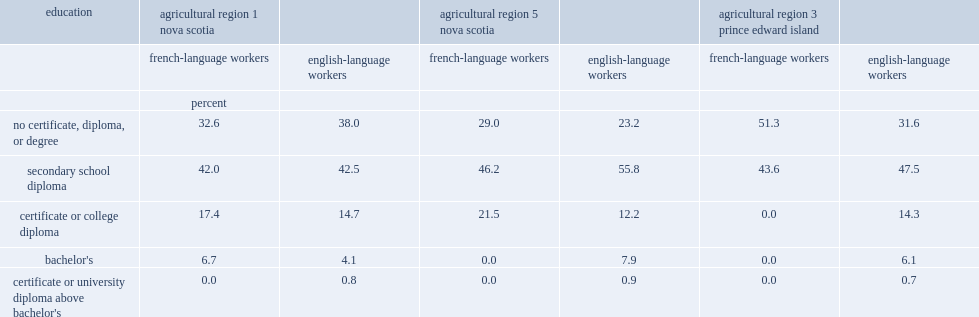Which sector of workers in nova scotia's agricultural region 5 and prince edward island's agricultural region 3 was more likely to have no certificate, diploma or degree? french-language workers or english-language workers? French-language workers. Which sector of workers was more likely to have a college certificate or diploma in nova scotia's agricultural region 5? french-language workers or english-language workers? French-language workers. Which sector of workers was less likely to have no certificate, diploma or degree in nova scotia's agricultural region 1? french-language workers or english-language workers? French-language workers. Which sector of workers was more likely to have a college certificate or diploma or a bachelor's degree in nova scotia's agricultural region 1? french-language workers or english-language workers? French-language workers. 